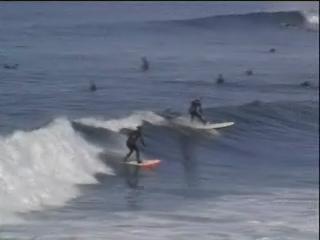How many surfers are present?
Give a very brief answer. 2. How many are surfing?
Give a very brief answer. 2. How many people are surfing in this picture?
Give a very brief answer. 2. How many people are wearing orange jackets?
Give a very brief answer. 0. 